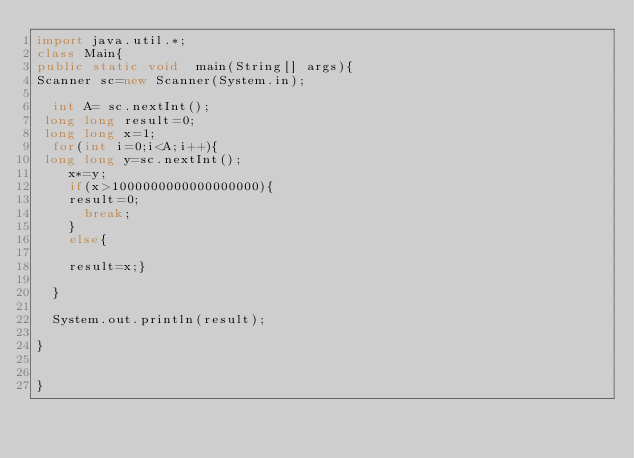<code> <loc_0><loc_0><loc_500><loc_500><_Java_>import java.util.*;
class Main{
public static void  main(String[] args){
Scanner sc=new Scanner(System.in);
  
  int A= sc.nextInt();
 long long result=0;
 long long x=1;
  for(int i=0;i<A;i++){
 long long y=sc.nextInt();
    x*=y;
    if(x>1000000000000000000){
    result=0;
      break;
    }
    else{
    
    result=x;}
  
  }
  
  System.out.println(result);

}


}
</code> 